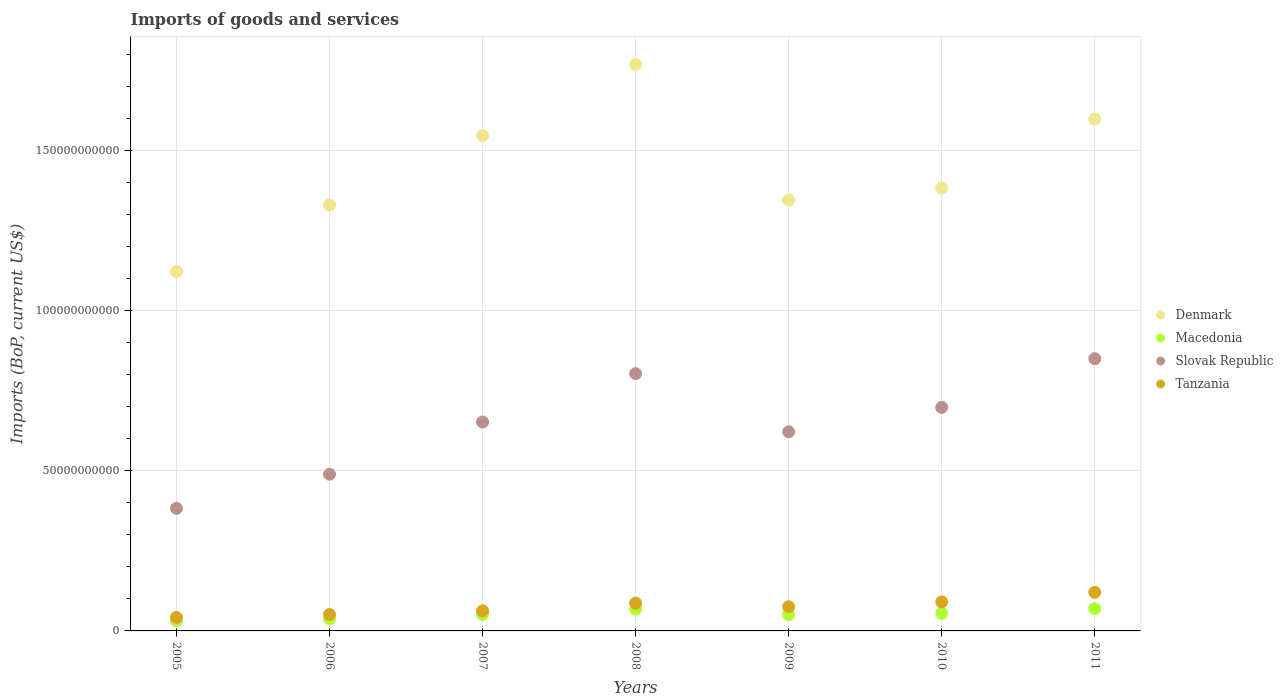How many different coloured dotlines are there?
Make the answer very short. 4. Is the number of dotlines equal to the number of legend labels?
Your response must be concise. Yes. What is the amount spent on imports in Slovak Republic in 2005?
Make the answer very short. 3.82e+1. Across all years, what is the maximum amount spent on imports in Denmark?
Make the answer very short. 1.77e+11. Across all years, what is the minimum amount spent on imports in Denmark?
Your answer should be very brief. 1.12e+11. In which year was the amount spent on imports in Denmark maximum?
Offer a very short reply. 2008. What is the total amount spent on imports in Macedonia in the graph?
Give a very brief answer. 3.65e+1. What is the difference between the amount spent on imports in Macedonia in 2005 and that in 2011?
Give a very brief answer. -3.75e+09. What is the difference between the amount spent on imports in Tanzania in 2011 and the amount spent on imports in Denmark in 2008?
Give a very brief answer. -1.65e+11. What is the average amount spent on imports in Macedonia per year?
Offer a terse response. 5.22e+09. In the year 2007, what is the difference between the amount spent on imports in Denmark and amount spent on imports in Tanzania?
Your answer should be compact. 1.48e+11. In how many years, is the amount spent on imports in Tanzania greater than 170000000000 US$?
Provide a short and direct response. 0. What is the ratio of the amount spent on imports in Slovak Republic in 2006 to that in 2011?
Provide a short and direct response. 0.58. Is the amount spent on imports in Denmark in 2007 less than that in 2009?
Make the answer very short. No. What is the difference between the highest and the second highest amount spent on imports in Tanzania?
Give a very brief answer. 2.98e+09. What is the difference between the highest and the lowest amount spent on imports in Macedonia?
Keep it short and to the point. 3.75e+09. Is the sum of the amount spent on imports in Tanzania in 2005 and 2011 greater than the maximum amount spent on imports in Denmark across all years?
Your answer should be very brief. No. Is it the case that in every year, the sum of the amount spent on imports in Slovak Republic and amount spent on imports in Tanzania  is greater than the amount spent on imports in Denmark?
Offer a very short reply. No. How many dotlines are there?
Your answer should be very brief. 4. How many years are there in the graph?
Make the answer very short. 7. How are the legend labels stacked?
Offer a very short reply. Vertical. What is the title of the graph?
Provide a short and direct response. Imports of goods and services. Does "Turkey" appear as one of the legend labels in the graph?
Offer a terse response. No. What is the label or title of the X-axis?
Your answer should be compact. Years. What is the label or title of the Y-axis?
Ensure brevity in your answer.  Imports (BoP, current US$). What is the Imports (BoP, current US$) of Denmark in 2005?
Make the answer very short. 1.12e+11. What is the Imports (BoP, current US$) in Macedonia in 2005?
Give a very brief answer. 3.19e+09. What is the Imports (BoP, current US$) of Slovak Republic in 2005?
Ensure brevity in your answer.  3.82e+1. What is the Imports (BoP, current US$) of Tanzania in 2005?
Ensure brevity in your answer.  4.20e+09. What is the Imports (BoP, current US$) of Denmark in 2006?
Provide a short and direct response. 1.33e+11. What is the Imports (BoP, current US$) of Macedonia in 2006?
Provide a short and direct response. 3.77e+09. What is the Imports (BoP, current US$) of Slovak Republic in 2006?
Your answer should be compact. 4.89e+1. What is the Imports (BoP, current US$) of Tanzania in 2006?
Your response must be concise. 5.11e+09. What is the Imports (BoP, current US$) of Denmark in 2007?
Your answer should be very brief. 1.55e+11. What is the Imports (BoP, current US$) of Macedonia in 2007?
Your answer should be very brief. 5.20e+09. What is the Imports (BoP, current US$) of Slovak Republic in 2007?
Keep it short and to the point. 6.52e+1. What is the Imports (BoP, current US$) in Tanzania in 2007?
Your answer should be very brief. 6.27e+09. What is the Imports (BoP, current US$) of Denmark in 2008?
Keep it short and to the point. 1.77e+11. What is the Imports (BoP, current US$) of Macedonia in 2008?
Offer a very short reply. 6.82e+09. What is the Imports (BoP, current US$) of Slovak Republic in 2008?
Your answer should be compact. 8.03e+1. What is the Imports (BoP, current US$) of Tanzania in 2008?
Your answer should be very brief. 8.67e+09. What is the Imports (BoP, current US$) in Denmark in 2009?
Make the answer very short. 1.34e+11. What is the Imports (BoP, current US$) in Macedonia in 2009?
Ensure brevity in your answer.  5.13e+09. What is the Imports (BoP, current US$) of Slovak Republic in 2009?
Your answer should be compact. 6.21e+1. What is the Imports (BoP, current US$) in Tanzania in 2009?
Ensure brevity in your answer.  7.56e+09. What is the Imports (BoP, current US$) of Denmark in 2010?
Provide a short and direct response. 1.38e+11. What is the Imports (BoP, current US$) of Macedonia in 2010?
Your answer should be very brief. 5.46e+09. What is the Imports (BoP, current US$) in Slovak Republic in 2010?
Your answer should be compact. 6.98e+1. What is the Imports (BoP, current US$) of Tanzania in 2010?
Ensure brevity in your answer.  9.05e+09. What is the Imports (BoP, current US$) of Denmark in 2011?
Keep it short and to the point. 1.60e+11. What is the Imports (BoP, current US$) in Macedonia in 2011?
Offer a very short reply. 6.93e+09. What is the Imports (BoP, current US$) in Slovak Republic in 2011?
Offer a very short reply. 8.50e+1. What is the Imports (BoP, current US$) in Tanzania in 2011?
Your answer should be very brief. 1.20e+1. Across all years, what is the maximum Imports (BoP, current US$) in Denmark?
Your answer should be very brief. 1.77e+11. Across all years, what is the maximum Imports (BoP, current US$) in Macedonia?
Make the answer very short. 6.93e+09. Across all years, what is the maximum Imports (BoP, current US$) of Slovak Republic?
Give a very brief answer. 8.50e+1. Across all years, what is the maximum Imports (BoP, current US$) in Tanzania?
Your answer should be very brief. 1.20e+1. Across all years, what is the minimum Imports (BoP, current US$) in Denmark?
Provide a succinct answer. 1.12e+11. Across all years, what is the minimum Imports (BoP, current US$) in Macedonia?
Your response must be concise. 3.19e+09. Across all years, what is the minimum Imports (BoP, current US$) of Slovak Republic?
Make the answer very short. 3.82e+1. Across all years, what is the minimum Imports (BoP, current US$) in Tanzania?
Give a very brief answer. 4.20e+09. What is the total Imports (BoP, current US$) of Denmark in the graph?
Provide a short and direct response. 1.01e+12. What is the total Imports (BoP, current US$) in Macedonia in the graph?
Your response must be concise. 3.65e+1. What is the total Imports (BoP, current US$) of Slovak Republic in the graph?
Ensure brevity in your answer.  4.50e+11. What is the total Imports (BoP, current US$) of Tanzania in the graph?
Make the answer very short. 5.29e+1. What is the difference between the Imports (BoP, current US$) in Denmark in 2005 and that in 2006?
Give a very brief answer. -2.08e+1. What is the difference between the Imports (BoP, current US$) in Macedonia in 2005 and that in 2006?
Your response must be concise. -5.85e+08. What is the difference between the Imports (BoP, current US$) in Slovak Republic in 2005 and that in 2006?
Make the answer very short. -1.07e+1. What is the difference between the Imports (BoP, current US$) in Tanzania in 2005 and that in 2006?
Your answer should be very brief. -9.09e+08. What is the difference between the Imports (BoP, current US$) in Denmark in 2005 and that in 2007?
Your answer should be very brief. -4.24e+1. What is the difference between the Imports (BoP, current US$) of Macedonia in 2005 and that in 2007?
Make the answer very short. -2.01e+09. What is the difference between the Imports (BoP, current US$) in Slovak Republic in 2005 and that in 2007?
Your answer should be very brief. -2.70e+1. What is the difference between the Imports (BoP, current US$) of Tanzania in 2005 and that in 2007?
Give a very brief answer. -2.07e+09. What is the difference between the Imports (BoP, current US$) in Denmark in 2005 and that in 2008?
Provide a short and direct response. -6.47e+1. What is the difference between the Imports (BoP, current US$) in Macedonia in 2005 and that in 2008?
Ensure brevity in your answer.  -3.63e+09. What is the difference between the Imports (BoP, current US$) of Slovak Republic in 2005 and that in 2008?
Provide a succinct answer. -4.20e+1. What is the difference between the Imports (BoP, current US$) of Tanzania in 2005 and that in 2008?
Provide a short and direct response. -4.47e+09. What is the difference between the Imports (BoP, current US$) of Denmark in 2005 and that in 2009?
Offer a terse response. -2.23e+1. What is the difference between the Imports (BoP, current US$) of Macedonia in 2005 and that in 2009?
Your answer should be compact. -1.94e+09. What is the difference between the Imports (BoP, current US$) of Slovak Republic in 2005 and that in 2009?
Ensure brevity in your answer.  -2.39e+1. What is the difference between the Imports (BoP, current US$) of Tanzania in 2005 and that in 2009?
Provide a short and direct response. -3.35e+09. What is the difference between the Imports (BoP, current US$) in Denmark in 2005 and that in 2010?
Provide a short and direct response. -2.61e+1. What is the difference between the Imports (BoP, current US$) of Macedonia in 2005 and that in 2010?
Give a very brief answer. -2.28e+09. What is the difference between the Imports (BoP, current US$) in Slovak Republic in 2005 and that in 2010?
Keep it short and to the point. -3.15e+1. What is the difference between the Imports (BoP, current US$) in Tanzania in 2005 and that in 2010?
Ensure brevity in your answer.  -4.85e+09. What is the difference between the Imports (BoP, current US$) in Denmark in 2005 and that in 2011?
Offer a very short reply. -4.76e+1. What is the difference between the Imports (BoP, current US$) of Macedonia in 2005 and that in 2011?
Your answer should be compact. -3.75e+09. What is the difference between the Imports (BoP, current US$) of Slovak Republic in 2005 and that in 2011?
Provide a succinct answer. -4.67e+1. What is the difference between the Imports (BoP, current US$) of Tanzania in 2005 and that in 2011?
Provide a succinct answer. -7.83e+09. What is the difference between the Imports (BoP, current US$) of Denmark in 2006 and that in 2007?
Give a very brief answer. -2.17e+1. What is the difference between the Imports (BoP, current US$) of Macedonia in 2006 and that in 2007?
Provide a short and direct response. -1.43e+09. What is the difference between the Imports (BoP, current US$) of Slovak Republic in 2006 and that in 2007?
Your answer should be very brief. -1.63e+1. What is the difference between the Imports (BoP, current US$) in Tanzania in 2006 and that in 2007?
Your response must be concise. -1.16e+09. What is the difference between the Imports (BoP, current US$) in Denmark in 2006 and that in 2008?
Offer a very short reply. -4.39e+1. What is the difference between the Imports (BoP, current US$) of Macedonia in 2006 and that in 2008?
Make the answer very short. -3.05e+09. What is the difference between the Imports (BoP, current US$) in Slovak Republic in 2006 and that in 2008?
Offer a terse response. -3.14e+1. What is the difference between the Imports (BoP, current US$) of Tanzania in 2006 and that in 2008?
Your response must be concise. -3.56e+09. What is the difference between the Imports (BoP, current US$) in Denmark in 2006 and that in 2009?
Ensure brevity in your answer.  -1.55e+09. What is the difference between the Imports (BoP, current US$) in Macedonia in 2006 and that in 2009?
Provide a succinct answer. -1.36e+09. What is the difference between the Imports (BoP, current US$) in Slovak Republic in 2006 and that in 2009?
Provide a succinct answer. -1.32e+1. What is the difference between the Imports (BoP, current US$) of Tanzania in 2006 and that in 2009?
Your answer should be very brief. -2.44e+09. What is the difference between the Imports (BoP, current US$) in Denmark in 2006 and that in 2010?
Give a very brief answer. -5.30e+09. What is the difference between the Imports (BoP, current US$) in Macedonia in 2006 and that in 2010?
Ensure brevity in your answer.  -1.69e+09. What is the difference between the Imports (BoP, current US$) of Slovak Republic in 2006 and that in 2010?
Provide a succinct answer. -2.09e+1. What is the difference between the Imports (BoP, current US$) of Tanzania in 2006 and that in 2010?
Ensure brevity in your answer.  -3.94e+09. What is the difference between the Imports (BoP, current US$) in Denmark in 2006 and that in 2011?
Your answer should be very brief. -2.68e+1. What is the difference between the Imports (BoP, current US$) in Macedonia in 2006 and that in 2011?
Offer a terse response. -3.16e+09. What is the difference between the Imports (BoP, current US$) in Slovak Republic in 2006 and that in 2011?
Provide a short and direct response. -3.61e+1. What is the difference between the Imports (BoP, current US$) in Tanzania in 2006 and that in 2011?
Offer a very short reply. -6.92e+09. What is the difference between the Imports (BoP, current US$) in Denmark in 2007 and that in 2008?
Provide a short and direct response. -2.22e+1. What is the difference between the Imports (BoP, current US$) in Macedonia in 2007 and that in 2008?
Provide a short and direct response. -1.62e+09. What is the difference between the Imports (BoP, current US$) in Slovak Republic in 2007 and that in 2008?
Give a very brief answer. -1.51e+1. What is the difference between the Imports (BoP, current US$) of Tanzania in 2007 and that in 2008?
Your response must be concise. -2.40e+09. What is the difference between the Imports (BoP, current US$) of Denmark in 2007 and that in 2009?
Make the answer very short. 2.01e+1. What is the difference between the Imports (BoP, current US$) in Macedonia in 2007 and that in 2009?
Keep it short and to the point. 6.79e+07. What is the difference between the Imports (BoP, current US$) of Slovak Republic in 2007 and that in 2009?
Your answer should be compact. 3.06e+09. What is the difference between the Imports (BoP, current US$) in Tanzania in 2007 and that in 2009?
Make the answer very short. -1.28e+09. What is the difference between the Imports (BoP, current US$) of Denmark in 2007 and that in 2010?
Provide a succinct answer. 1.64e+1. What is the difference between the Imports (BoP, current US$) in Macedonia in 2007 and that in 2010?
Provide a short and direct response. -2.63e+08. What is the difference between the Imports (BoP, current US$) in Slovak Republic in 2007 and that in 2010?
Offer a very short reply. -4.56e+09. What is the difference between the Imports (BoP, current US$) in Tanzania in 2007 and that in 2010?
Your answer should be compact. -2.78e+09. What is the difference between the Imports (BoP, current US$) in Denmark in 2007 and that in 2011?
Offer a very short reply. -5.16e+09. What is the difference between the Imports (BoP, current US$) in Macedonia in 2007 and that in 2011?
Keep it short and to the point. -1.73e+09. What is the difference between the Imports (BoP, current US$) in Slovak Republic in 2007 and that in 2011?
Your response must be concise. -1.98e+1. What is the difference between the Imports (BoP, current US$) of Tanzania in 2007 and that in 2011?
Keep it short and to the point. -5.76e+09. What is the difference between the Imports (BoP, current US$) in Denmark in 2008 and that in 2009?
Give a very brief answer. 4.23e+1. What is the difference between the Imports (BoP, current US$) in Macedonia in 2008 and that in 2009?
Offer a terse response. 1.69e+09. What is the difference between the Imports (BoP, current US$) of Slovak Republic in 2008 and that in 2009?
Keep it short and to the point. 1.81e+1. What is the difference between the Imports (BoP, current US$) in Tanzania in 2008 and that in 2009?
Your answer should be very brief. 1.12e+09. What is the difference between the Imports (BoP, current US$) of Denmark in 2008 and that in 2010?
Keep it short and to the point. 3.86e+1. What is the difference between the Imports (BoP, current US$) of Macedonia in 2008 and that in 2010?
Keep it short and to the point. 1.36e+09. What is the difference between the Imports (BoP, current US$) of Slovak Republic in 2008 and that in 2010?
Provide a short and direct response. 1.05e+1. What is the difference between the Imports (BoP, current US$) in Tanzania in 2008 and that in 2010?
Provide a short and direct response. -3.80e+08. What is the difference between the Imports (BoP, current US$) of Denmark in 2008 and that in 2011?
Keep it short and to the point. 1.71e+1. What is the difference between the Imports (BoP, current US$) in Macedonia in 2008 and that in 2011?
Your answer should be compact. -1.15e+08. What is the difference between the Imports (BoP, current US$) of Slovak Republic in 2008 and that in 2011?
Offer a very short reply. -4.66e+09. What is the difference between the Imports (BoP, current US$) of Tanzania in 2008 and that in 2011?
Your answer should be compact. -3.36e+09. What is the difference between the Imports (BoP, current US$) of Denmark in 2009 and that in 2010?
Make the answer very short. -3.75e+09. What is the difference between the Imports (BoP, current US$) of Macedonia in 2009 and that in 2010?
Provide a succinct answer. -3.31e+08. What is the difference between the Imports (BoP, current US$) in Slovak Republic in 2009 and that in 2010?
Make the answer very short. -7.61e+09. What is the difference between the Imports (BoP, current US$) of Tanzania in 2009 and that in 2010?
Your answer should be compact. -1.50e+09. What is the difference between the Imports (BoP, current US$) of Denmark in 2009 and that in 2011?
Offer a terse response. -2.53e+1. What is the difference between the Imports (BoP, current US$) in Macedonia in 2009 and that in 2011?
Provide a succinct answer. -1.80e+09. What is the difference between the Imports (BoP, current US$) in Slovak Republic in 2009 and that in 2011?
Your answer should be compact. -2.28e+1. What is the difference between the Imports (BoP, current US$) in Tanzania in 2009 and that in 2011?
Provide a short and direct response. -4.48e+09. What is the difference between the Imports (BoP, current US$) in Denmark in 2010 and that in 2011?
Keep it short and to the point. -2.15e+1. What is the difference between the Imports (BoP, current US$) in Macedonia in 2010 and that in 2011?
Your answer should be very brief. -1.47e+09. What is the difference between the Imports (BoP, current US$) in Slovak Republic in 2010 and that in 2011?
Provide a succinct answer. -1.52e+1. What is the difference between the Imports (BoP, current US$) in Tanzania in 2010 and that in 2011?
Your response must be concise. -2.98e+09. What is the difference between the Imports (BoP, current US$) of Denmark in 2005 and the Imports (BoP, current US$) of Macedonia in 2006?
Ensure brevity in your answer.  1.08e+11. What is the difference between the Imports (BoP, current US$) in Denmark in 2005 and the Imports (BoP, current US$) in Slovak Republic in 2006?
Give a very brief answer. 6.33e+1. What is the difference between the Imports (BoP, current US$) of Denmark in 2005 and the Imports (BoP, current US$) of Tanzania in 2006?
Offer a terse response. 1.07e+11. What is the difference between the Imports (BoP, current US$) in Macedonia in 2005 and the Imports (BoP, current US$) in Slovak Republic in 2006?
Your answer should be very brief. -4.57e+1. What is the difference between the Imports (BoP, current US$) in Macedonia in 2005 and the Imports (BoP, current US$) in Tanzania in 2006?
Give a very brief answer. -1.93e+09. What is the difference between the Imports (BoP, current US$) of Slovak Republic in 2005 and the Imports (BoP, current US$) of Tanzania in 2006?
Your answer should be very brief. 3.31e+1. What is the difference between the Imports (BoP, current US$) in Denmark in 2005 and the Imports (BoP, current US$) in Macedonia in 2007?
Keep it short and to the point. 1.07e+11. What is the difference between the Imports (BoP, current US$) of Denmark in 2005 and the Imports (BoP, current US$) of Slovak Republic in 2007?
Provide a short and direct response. 4.69e+1. What is the difference between the Imports (BoP, current US$) in Denmark in 2005 and the Imports (BoP, current US$) in Tanzania in 2007?
Your response must be concise. 1.06e+11. What is the difference between the Imports (BoP, current US$) in Macedonia in 2005 and the Imports (BoP, current US$) in Slovak Republic in 2007?
Your response must be concise. -6.20e+1. What is the difference between the Imports (BoP, current US$) of Macedonia in 2005 and the Imports (BoP, current US$) of Tanzania in 2007?
Give a very brief answer. -3.09e+09. What is the difference between the Imports (BoP, current US$) of Slovak Republic in 2005 and the Imports (BoP, current US$) of Tanzania in 2007?
Give a very brief answer. 3.20e+1. What is the difference between the Imports (BoP, current US$) in Denmark in 2005 and the Imports (BoP, current US$) in Macedonia in 2008?
Give a very brief answer. 1.05e+11. What is the difference between the Imports (BoP, current US$) in Denmark in 2005 and the Imports (BoP, current US$) in Slovak Republic in 2008?
Keep it short and to the point. 3.19e+1. What is the difference between the Imports (BoP, current US$) in Denmark in 2005 and the Imports (BoP, current US$) in Tanzania in 2008?
Give a very brief answer. 1.03e+11. What is the difference between the Imports (BoP, current US$) of Macedonia in 2005 and the Imports (BoP, current US$) of Slovak Republic in 2008?
Offer a terse response. -7.71e+1. What is the difference between the Imports (BoP, current US$) in Macedonia in 2005 and the Imports (BoP, current US$) in Tanzania in 2008?
Offer a very short reply. -5.49e+09. What is the difference between the Imports (BoP, current US$) of Slovak Republic in 2005 and the Imports (BoP, current US$) of Tanzania in 2008?
Give a very brief answer. 2.96e+1. What is the difference between the Imports (BoP, current US$) of Denmark in 2005 and the Imports (BoP, current US$) of Macedonia in 2009?
Your response must be concise. 1.07e+11. What is the difference between the Imports (BoP, current US$) in Denmark in 2005 and the Imports (BoP, current US$) in Slovak Republic in 2009?
Your answer should be very brief. 5.00e+1. What is the difference between the Imports (BoP, current US$) in Denmark in 2005 and the Imports (BoP, current US$) in Tanzania in 2009?
Keep it short and to the point. 1.05e+11. What is the difference between the Imports (BoP, current US$) of Macedonia in 2005 and the Imports (BoP, current US$) of Slovak Republic in 2009?
Your response must be concise. -5.90e+1. What is the difference between the Imports (BoP, current US$) of Macedonia in 2005 and the Imports (BoP, current US$) of Tanzania in 2009?
Your answer should be compact. -4.37e+09. What is the difference between the Imports (BoP, current US$) in Slovak Republic in 2005 and the Imports (BoP, current US$) in Tanzania in 2009?
Offer a terse response. 3.07e+1. What is the difference between the Imports (BoP, current US$) of Denmark in 2005 and the Imports (BoP, current US$) of Macedonia in 2010?
Your response must be concise. 1.07e+11. What is the difference between the Imports (BoP, current US$) of Denmark in 2005 and the Imports (BoP, current US$) of Slovak Republic in 2010?
Provide a short and direct response. 4.24e+1. What is the difference between the Imports (BoP, current US$) of Denmark in 2005 and the Imports (BoP, current US$) of Tanzania in 2010?
Keep it short and to the point. 1.03e+11. What is the difference between the Imports (BoP, current US$) of Macedonia in 2005 and the Imports (BoP, current US$) of Slovak Republic in 2010?
Your answer should be very brief. -6.66e+1. What is the difference between the Imports (BoP, current US$) in Macedonia in 2005 and the Imports (BoP, current US$) in Tanzania in 2010?
Provide a short and direct response. -5.87e+09. What is the difference between the Imports (BoP, current US$) of Slovak Republic in 2005 and the Imports (BoP, current US$) of Tanzania in 2010?
Ensure brevity in your answer.  2.92e+1. What is the difference between the Imports (BoP, current US$) of Denmark in 2005 and the Imports (BoP, current US$) of Macedonia in 2011?
Offer a very short reply. 1.05e+11. What is the difference between the Imports (BoP, current US$) in Denmark in 2005 and the Imports (BoP, current US$) in Slovak Republic in 2011?
Keep it short and to the point. 2.72e+1. What is the difference between the Imports (BoP, current US$) of Denmark in 2005 and the Imports (BoP, current US$) of Tanzania in 2011?
Keep it short and to the point. 1.00e+11. What is the difference between the Imports (BoP, current US$) of Macedonia in 2005 and the Imports (BoP, current US$) of Slovak Republic in 2011?
Make the answer very short. -8.18e+1. What is the difference between the Imports (BoP, current US$) of Macedonia in 2005 and the Imports (BoP, current US$) of Tanzania in 2011?
Your answer should be very brief. -8.85e+09. What is the difference between the Imports (BoP, current US$) in Slovak Republic in 2005 and the Imports (BoP, current US$) in Tanzania in 2011?
Your answer should be compact. 2.62e+1. What is the difference between the Imports (BoP, current US$) of Denmark in 2006 and the Imports (BoP, current US$) of Macedonia in 2007?
Give a very brief answer. 1.28e+11. What is the difference between the Imports (BoP, current US$) of Denmark in 2006 and the Imports (BoP, current US$) of Slovak Republic in 2007?
Your response must be concise. 6.77e+1. What is the difference between the Imports (BoP, current US$) in Denmark in 2006 and the Imports (BoP, current US$) in Tanzania in 2007?
Give a very brief answer. 1.27e+11. What is the difference between the Imports (BoP, current US$) of Macedonia in 2006 and the Imports (BoP, current US$) of Slovak Republic in 2007?
Offer a very short reply. -6.14e+1. What is the difference between the Imports (BoP, current US$) in Macedonia in 2006 and the Imports (BoP, current US$) in Tanzania in 2007?
Provide a short and direct response. -2.50e+09. What is the difference between the Imports (BoP, current US$) of Slovak Republic in 2006 and the Imports (BoP, current US$) of Tanzania in 2007?
Keep it short and to the point. 4.26e+1. What is the difference between the Imports (BoP, current US$) in Denmark in 2006 and the Imports (BoP, current US$) in Macedonia in 2008?
Provide a succinct answer. 1.26e+11. What is the difference between the Imports (BoP, current US$) of Denmark in 2006 and the Imports (BoP, current US$) of Slovak Republic in 2008?
Make the answer very short. 5.26e+1. What is the difference between the Imports (BoP, current US$) in Denmark in 2006 and the Imports (BoP, current US$) in Tanzania in 2008?
Provide a short and direct response. 1.24e+11. What is the difference between the Imports (BoP, current US$) of Macedonia in 2006 and the Imports (BoP, current US$) of Slovak Republic in 2008?
Offer a very short reply. -7.65e+1. What is the difference between the Imports (BoP, current US$) of Macedonia in 2006 and the Imports (BoP, current US$) of Tanzania in 2008?
Make the answer very short. -4.90e+09. What is the difference between the Imports (BoP, current US$) in Slovak Republic in 2006 and the Imports (BoP, current US$) in Tanzania in 2008?
Your answer should be compact. 4.02e+1. What is the difference between the Imports (BoP, current US$) of Denmark in 2006 and the Imports (BoP, current US$) of Macedonia in 2009?
Your answer should be very brief. 1.28e+11. What is the difference between the Imports (BoP, current US$) in Denmark in 2006 and the Imports (BoP, current US$) in Slovak Republic in 2009?
Offer a terse response. 7.08e+1. What is the difference between the Imports (BoP, current US$) in Denmark in 2006 and the Imports (BoP, current US$) in Tanzania in 2009?
Your answer should be compact. 1.25e+11. What is the difference between the Imports (BoP, current US$) in Macedonia in 2006 and the Imports (BoP, current US$) in Slovak Republic in 2009?
Keep it short and to the point. -5.84e+1. What is the difference between the Imports (BoP, current US$) of Macedonia in 2006 and the Imports (BoP, current US$) of Tanzania in 2009?
Provide a short and direct response. -3.78e+09. What is the difference between the Imports (BoP, current US$) of Slovak Republic in 2006 and the Imports (BoP, current US$) of Tanzania in 2009?
Offer a terse response. 4.13e+1. What is the difference between the Imports (BoP, current US$) in Denmark in 2006 and the Imports (BoP, current US$) in Macedonia in 2010?
Offer a terse response. 1.27e+11. What is the difference between the Imports (BoP, current US$) in Denmark in 2006 and the Imports (BoP, current US$) in Slovak Republic in 2010?
Provide a succinct answer. 6.32e+1. What is the difference between the Imports (BoP, current US$) in Denmark in 2006 and the Imports (BoP, current US$) in Tanzania in 2010?
Keep it short and to the point. 1.24e+11. What is the difference between the Imports (BoP, current US$) in Macedonia in 2006 and the Imports (BoP, current US$) in Slovak Republic in 2010?
Make the answer very short. -6.60e+1. What is the difference between the Imports (BoP, current US$) in Macedonia in 2006 and the Imports (BoP, current US$) in Tanzania in 2010?
Ensure brevity in your answer.  -5.28e+09. What is the difference between the Imports (BoP, current US$) in Slovak Republic in 2006 and the Imports (BoP, current US$) in Tanzania in 2010?
Your answer should be very brief. 3.98e+1. What is the difference between the Imports (BoP, current US$) in Denmark in 2006 and the Imports (BoP, current US$) in Macedonia in 2011?
Keep it short and to the point. 1.26e+11. What is the difference between the Imports (BoP, current US$) of Denmark in 2006 and the Imports (BoP, current US$) of Slovak Republic in 2011?
Ensure brevity in your answer.  4.80e+1. What is the difference between the Imports (BoP, current US$) in Denmark in 2006 and the Imports (BoP, current US$) in Tanzania in 2011?
Your answer should be very brief. 1.21e+11. What is the difference between the Imports (BoP, current US$) of Macedonia in 2006 and the Imports (BoP, current US$) of Slovak Republic in 2011?
Your response must be concise. -8.12e+1. What is the difference between the Imports (BoP, current US$) of Macedonia in 2006 and the Imports (BoP, current US$) of Tanzania in 2011?
Your response must be concise. -8.26e+09. What is the difference between the Imports (BoP, current US$) in Slovak Republic in 2006 and the Imports (BoP, current US$) in Tanzania in 2011?
Give a very brief answer. 3.69e+1. What is the difference between the Imports (BoP, current US$) in Denmark in 2007 and the Imports (BoP, current US$) in Macedonia in 2008?
Make the answer very short. 1.48e+11. What is the difference between the Imports (BoP, current US$) in Denmark in 2007 and the Imports (BoP, current US$) in Slovak Republic in 2008?
Your answer should be compact. 7.43e+1. What is the difference between the Imports (BoP, current US$) in Denmark in 2007 and the Imports (BoP, current US$) in Tanzania in 2008?
Your answer should be very brief. 1.46e+11. What is the difference between the Imports (BoP, current US$) of Macedonia in 2007 and the Imports (BoP, current US$) of Slovak Republic in 2008?
Make the answer very short. -7.51e+1. What is the difference between the Imports (BoP, current US$) in Macedonia in 2007 and the Imports (BoP, current US$) in Tanzania in 2008?
Offer a terse response. -3.47e+09. What is the difference between the Imports (BoP, current US$) in Slovak Republic in 2007 and the Imports (BoP, current US$) in Tanzania in 2008?
Offer a very short reply. 5.65e+1. What is the difference between the Imports (BoP, current US$) in Denmark in 2007 and the Imports (BoP, current US$) in Macedonia in 2009?
Keep it short and to the point. 1.49e+11. What is the difference between the Imports (BoP, current US$) in Denmark in 2007 and the Imports (BoP, current US$) in Slovak Republic in 2009?
Your response must be concise. 9.24e+1. What is the difference between the Imports (BoP, current US$) in Denmark in 2007 and the Imports (BoP, current US$) in Tanzania in 2009?
Keep it short and to the point. 1.47e+11. What is the difference between the Imports (BoP, current US$) of Macedonia in 2007 and the Imports (BoP, current US$) of Slovak Republic in 2009?
Your answer should be very brief. -5.69e+1. What is the difference between the Imports (BoP, current US$) in Macedonia in 2007 and the Imports (BoP, current US$) in Tanzania in 2009?
Offer a terse response. -2.36e+09. What is the difference between the Imports (BoP, current US$) in Slovak Republic in 2007 and the Imports (BoP, current US$) in Tanzania in 2009?
Your answer should be very brief. 5.77e+1. What is the difference between the Imports (BoP, current US$) of Denmark in 2007 and the Imports (BoP, current US$) of Macedonia in 2010?
Provide a succinct answer. 1.49e+11. What is the difference between the Imports (BoP, current US$) in Denmark in 2007 and the Imports (BoP, current US$) in Slovak Republic in 2010?
Give a very brief answer. 8.48e+1. What is the difference between the Imports (BoP, current US$) in Denmark in 2007 and the Imports (BoP, current US$) in Tanzania in 2010?
Your response must be concise. 1.46e+11. What is the difference between the Imports (BoP, current US$) of Macedonia in 2007 and the Imports (BoP, current US$) of Slovak Republic in 2010?
Offer a very short reply. -6.46e+1. What is the difference between the Imports (BoP, current US$) of Macedonia in 2007 and the Imports (BoP, current US$) of Tanzania in 2010?
Your response must be concise. -3.85e+09. What is the difference between the Imports (BoP, current US$) in Slovak Republic in 2007 and the Imports (BoP, current US$) in Tanzania in 2010?
Your answer should be very brief. 5.62e+1. What is the difference between the Imports (BoP, current US$) of Denmark in 2007 and the Imports (BoP, current US$) of Macedonia in 2011?
Keep it short and to the point. 1.48e+11. What is the difference between the Imports (BoP, current US$) of Denmark in 2007 and the Imports (BoP, current US$) of Slovak Republic in 2011?
Provide a short and direct response. 6.96e+1. What is the difference between the Imports (BoP, current US$) in Denmark in 2007 and the Imports (BoP, current US$) in Tanzania in 2011?
Keep it short and to the point. 1.43e+11. What is the difference between the Imports (BoP, current US$) of Macedonia in 2007 and the Imports (BoP, current US$) of Slovak Republic in 2011?
Provide a short and direct response. -7.98e+1. What is the difference between the Imports (BoP, current US$) in Macedonia in 2007 and the Imports (BoP, current US$) in Tanzania in 2011?
Make the answer very short. -6.84e+09. What is the difference between the Imports (BoP, current US$) of Slovak Republic in 2007 and the Imports (BoP, current US$) of Tanzania in 2011?
Give a very brief answer. 5.32e+1. What is the difference between the Imports (BoP, current US$) in Denmark in 2008 and the Imports (BoP, current US$) in Macedonia in 2009?
Provide a short and direct response. 1.72e+11. What is the difference between the Imports (BoP, current US$) of Denmark in 2008 and the Imports (BoP, current US$) of Slovak Republic in 2009?
Provide a succinct answer. 1.15e+11. What is the difference between the Imports (BoP, current US$) of Denmark in 2008 and the Imports (BoP, current US$) of Tanzania in 2009?
Your answer should be compact. 1.69e+11. What is the difference between the Imports (BoP, current US$) of Macedonia in 2008 and the Imports (BoP, current US$) of Slovak Republic in 2009?
Make the answer very short. -5.53e+1. What is the difference between the Imports (BoP, current US$) in Macedonia in 2008 and the Imports (BoP, current US$) in Tanzania in 2009?
Provide a short and direct response. -7.37e+08. What is the difference between the Imports (BoP, current US$) of Slovak Republic in 2008 and the Imports (BoP, current US$) of Tanzania in 2009?
Ensure brevity in your answer.  7.27e+1. What is the difference between the Imports (BoP, current US$) of Denmark in 2008 and the Imports (BoP, current US$) of Macedonia in 2010?
Keep it short and to the point. 1.71e+11. What is the difference between the Imports (BoP, current US$) of Denmark in 2008 and the Imports (BoP, current US$) of Slovak Republic in 2010?
Ensure brevity in your answer.  1.07e+11. What is the difference between the Imports (BoP, current US$) of Denmark in 2008 and the Imports (BoP, current US$) of Tanzania in 2010?
Your answer should be very brief. 1.68e+11. What is the difference between the Imports (BoP, current US$) in Macedonia in 2008 and the Imports (BoP, current US$) in Slovak Republic in 2010?
Your response must be concise. -6.29e+1. What is the difference between the Imports (BoP, current US$) of Macedonia in 2008 and the Imports (BoP, current US$) of Tanzania in 2010?
Provide a short and direct response. -2.23e+09. What is the difference between the Imports (BoP, current US$) of Slovak Republic in 2008 and the Imports (BoP, current US$) of Tanzania in 2010?
Offer a very short reply. 7.12e+1. What is the difference between the Imports (BoP, current US$) of Denmark in 2008 and the Imports (BoP, current US$) of Macedonia in 2011?
Provide a short and direct response. 1.70e+11. What is the difference between the Imports (BoP, current US$) in Denmark in 2008 and the Imports (BoP, current US$) in Slovak Republic in 2011?
Offer a terse response. 9.19e+1. What is the difference between the Imports (BoP, current US$) of Denmark in 2008 and the Imports (BoP, current US$) of Tanzania in 2011?
Make the answer very short. 1.65e+11. What is the difference between the Imports (BoP, current US$) of Macedonia in 2008 and the Imports (BoP, current US$) of Slovak Republic in 2011?
Your answer should be compact. -7.81e+1. What is the difference between the Imports (BoP, current US$) of Macedonia in 2008 and the Imports (BoP, current US$) of Tanzania in 2011?
Provide a succinct answer. -5.22e+09. What is the difference between the Imports (BoP, current US$) in Slovak Republic in 2008 and the Imports (BoP, current US$) in Tanzania in 2011?
Offer a very short reply. 6.83e+1. What is the difference between the Imports (BoP, current US$) of Denmark in 2009 and the Imports (BoP, current US$) of Macedonia in 2010?
Make the answer very short. 1.29e+11. What is the difference between the Imports (BoP, current US$) of Denmark in 2009 and the Imports (BoP, current US$) of Slovak Republic in 2010?
Make the answer very short. 6.47e+1. What is the difference between the Imports (BoP, current US$) of Denmark in 2009 and the Imports (BoP, current US$) of Tanzania in 2010?
Your answer should be very brief. 1.25e+11. What is the difference between the Imports (BoP, current US$) of Macedonia in 2009 and the Imports (BoP, current US$) of Slovak Republic in 2010?
Provide a short and direct response. -6.46e+1. What is the difference between the Imports (BoP, current US$) in Macedonia in 2009 and the Imports (BoP, current US$) in Tanzania in 2010?
Make the answer very short. -3.92e+09. What is the difference between the Imports (BoP, current US$) in Slovak Republic in 2009 and the Imports (BoP, current US$) in Tanzania in 2010?
Your response must be concise. 5.31e+1. What is the difference between the Imports (BoP, current US$) in Denmark in 2009 and the Imports (BoP, current US$) in Macedonia in 2011?
Make the answer very short. 1.28e+11. What is the difference between the Imports (BoP, current US$) in Denmark in 2009 and the Imports (BoP, current US$) in Slovak Republic in 2011?
Your answer should be very brief. 4.95e+1. What is the difference between the Imports (BoP, current US$) of Denmark in 2009 and the Imports (BoP, current US$) of Tanzania in 2011?
Offer a very short reply. 1.22e+11. What is the difference between the Imports (BoP, current US$) in Macedonia in 2009 and the Imports (BoP, current US$) in Slovak Republic in 2011?
Offer a terse response. -7.98e+1. What is the difference between the Imports (BoP, current US$) of Macedonia in 2009 and the Imports (BoP, current US$) of Tanzania in 2011?
Your answer should be compact. -6.90e+09. What is the difference between the Imports (BoP, current US$) in Slovak Republic in 2009 and the Imports (BoP, current US$) in Tanzania in 2011?
Offer a very short reply. 5.01e+1. What is the difference between the Imports (BoP, current US$) in Denmark in 2010 and the Imports (BoP, current US$) in Macedonia in 2011?
Offer a very short reply. 1.31e+11. What is the difference between the Imports (BoP, current US$) in Denmark in 2010 and the Imports (BoP, current US$) in Slovak Republic in 2011?
Offer a very short reply. 5.33e+1. What is the difference between the Imports (BoP, current US$) of Denmark in 2010 and the Imports (BoP, current US$) of Tanzania in 2011?
Ensure brevity in your answer.  1.26e+11. What is the difference between the Imports (BoP, current US$) of Macedonia in 2010 and the Imports (BoP, current US$) of Slovak Republic in 2011?
Ensure brevity in your answer.  -7.95e+1. What is the difference between the Imports (BoP, current US$) of Macedonia in 2010 and the Imports (BoP, current US$) of Tanzania in 2011?
Your response must be concise. -6.57e+09. What is the difference between the Imports (BoP, current US$) in Slovak Republic in 2010 and the Imports (BoP, current US$) in Tanzania in 2011?
Your answer should be very brief. 5.77e+1. What is the average Imports (BoP, current US$) in Denmark per year?
Your response must be concise. 1.44e+11. What is the average Imports (BoP, current US$) of Macedonia per year?
Your response must be concise. 5.22e+09. What is the average Imports (BoP, current US$) of Slovak Republic per year?
Your answer should be very brief. 6.42e+1. What is the average Imports (BoP, current US$) in Tanzania per year?
Your answer should be compact. 7.56e+09. In the year 2005, what is the difference between the Imports (BoP, current US$) in Denmark and Imports (BoP, current US$) in Macedonia?
Provide a short and direct response. 1.09e+11. In the year 2005, what is the difference between the Imports (BoP, current US$) of Denmark and Imports (BoP, current US$) of Slovak Republic?
Offer a very short reply. 7.39e+1. In the year 2005, what is the difference between the Imports (BoP, current US$) in Denmark and Imports (BoP, current US$) in Tanzania?
Keep it short and to the point. 1.08e+11. In the year 2005, what is the difference between the Imports (BoP, current US$) in Macedonia and Imports (BoP, current US$) in Slovak Republic?
Your answer should be very brief. -3.51e+1. In the year 2005, what is the difference between the Imports (BoP, current US$) in Macedonia and Imports (BoP, current US$) in Tanzania?
Provide a succinct answer. -1.02e+09. In the year 2005, what is the difference between the Imports (BoP, current US$) in Slovak Republic and Imports (BoP, current US$) in Tanzania?
Provide a succinct answer. 3.40e+1. In the year 2006, what is the difference between the Imports (BoP, current US$) in Denmark and Imports (BoP, current US$) in Macedonia?
Give a very brief answer. 1.29e+11. In the year 2006, what is the difference between the Imports (BoP, current US$) of Denmark and Imports (BoP, current US$) of Slovak Republic?
Make the answer very short. 8.40e+1. In the year 2006, what is the difference between the Imports (BoP, current US$) of Denmark and Imports (BoP, current US$) of Tanzania?
Your answer should be very brief. 1.28e+11. In the year 2006, what is the difference between the Imports (BoP, current US$) in Macedonia and Imports (BoP, current US$) in Slovak Republic?
Offer a very short reply. -4.51e+1. In the year 2006, what is the difference between the Imports (BoP, current US$) of Macedonia and Imports (BoP, current US$) of Tanzania?
Your answer should be very brief. -1.34e+09. In the year 2006, what is the difference between the Imports (BoP, current US$) in Slovak Republic and Imports (BoP, current US$) in Tanzania?
Give a very brief answer. 4.38e+1. In the year 2007, what is the difference between the Imports (BoP, current US$) of Denmark and Imports (BoP, current US$) of Macedonia?
Ensure brevity in your answer.  1.49e+11. In the year 2007, what is the difference between the Imports (BoP, current US$) in Denmark and Imports (BoP, current US$) in Slovak Republic?
Ensure brevity in your answer.  8.94e+1. In the year 2007, what is the difference between the Imports (BoP, current US$) of Denmark and Imports (BoP, current US$) of Tanzania?
Offer a terse response. 1.48e+11. In the year 2007, what is the difference between the Imports (BoP, current US$) of Macedonia and Imports (BoP, current US$) of Slovak Republic?
Provide a short and direct response. -6.00e+1. In the year 2007, what is the difference between the Imports (BoP, current US$) of Macedonia and Imports (BoP, current US$) of Tanzania?
Provide a short and direct response. -1.07e+09. In the year 2007, what is the difference between the Imports (BoP, current US$) in Slovak Republic and Imports (BoP, current US$) in Tanzania?
Offer a very short reply. 5.89e+1. In the year 2008, what is the difference between the Imports (BoP, current US$) in Denmark and Imports (BoP, current US$) in Macedonia?
Your answer should be compact. 1.70e+11. In the year 2008, what is the difference between the Imports (BoP, current US$) in Denmark and Imports (BoP, current US$) in Slovak Republic?
Your answer should be compact. 9.65e+1. In the year 2008, what is the difference between the Imports (BoP, current US$) in Denmark and Imports (BoP, current US$) in Tanzania?
Your answer should be compact. 1.68e+11. In the year 2008, what is the difference between the Imports (BoP, current US$) in Macedonia and Imports (BoP, current US$) in Slovak Republic?
Give a very brief answer. -7.35e+1. In the year 2008, what is the difference between the Imports (BoP, current US$) in Macedonia and Imports (BoP, current US$) in Tanzania?
Provide a short and direct response. -1.85e+09. In the year 2008, what is the difference between the Imports (BoP, current US$) of Slovak Republic and Imports (BoP, current US$) of Tanzania?
Give a very brief answer. 7.16e+1. In the year 2009, what is the difference between the Imports (BoP, current US$) in Denmark and Imports (BoP, current US$) in Macedonia?
Offer a very short reply. 1.29e+11. In the year 2009, what is the difference between the Imports (BoP, current US$) of Denmark and Imports (BoP, current US$) of Slovak Republic?
Keep it short and to the point. 7.23e+1. In the year 2009, what is the difference between the Imports (BoP, current US$) of Denmark and Imports (BoP, current US$) of Tanzania?
Provide a succinct answer. 1.27e+11. In the year 2009, what is the difference between the Imports (BoP, current US$) in Macedonia and Imports (BoP, current US$) in Slovak Republic?
Your answer should be compact. -5.70e+1. In the year 2009, what is the difference between the Imports (BoP, current US$) in Macedonia and Imports (BoP, current US$) in Tanzania?
Keep it short and to the point. -2.42e+09. In the year 2009, what is the difference between the Imports (BoP, current US$) in Slovak Republic and Imports (BoP, current US$) in Tanzania?
Offer a terse response. 5.46e+1. In the year 2010, what is the difference between the Imports (BoP, current US$) of Denmark and Imports (BoP, current US$) of Macedonia?
Offer a terse response. 1.33e+11. In the year 2010, what is the difference between the Imports (BoP, current US$) in Denmark and Imports (BoP, current US$) in Slovak Republic?
Provide a short and direct response. 6.85e+1. In the year 2010, what is the difference between the Imports (BoP, current US$) of Denmark and Imports (BoP, current US$) of Tanzania?
Your answer should be very brief. 1.29e+11. In the year 2010, what is the difference between the Imports (BoP, current US$) in Macedonia and Imports (BoP, current US$) in Slovak Republic?
Give a very brief answer. -6.43e+1. In the year 2010, what is the difference between the Imports (BoP, current US$) in Macedonia and Imports (BoP, current US$) in Tanzania?
Make the answer very short. -3.59e+09. In the year 2010, what is the difference between the Imports (BoP, current US$) in Slovak Republic and Imports (BoP, current US$) in Tanzania?
Ensure brevity in your answer.  6.07e+1. In the year 2011, what is the difference between the Imports (BoP, current US$) in Denmark and Imports (BoP, current US$) in Macedonia?
Provide a short and direct response. 1.53e+11. In the year 2011, what is the difference between the Imports (BoP, current US$) of Denmark and Imports (BoP, current US$) of Slovak Republic?
Offer a very short reply. 7.48e+1. In the year 2011, what is the difference between the Imports (BoP, current US$) in Denmark and Imports (BoP, current US$) in Tanzania?
Your answer should be compact. 1.48e+11. In the year 2011, what is the difference between the Imports (BoP, current US$) of Macedonia and Imports (BoP, current US$) of Slovak Republic?
Your answer should be compact. -7.80e+1. In the year 2011, what is the difference between the Imports (BoP, current US$) in Macedonia and Imports (BoP, current US$) in Tanzania?
Your answer should be compact. -5.10e+09. In the year 2011, what is the difference between the Imports (BoP, current US$) of Slovak Republic and Imports (BoP, current US$) of Tanzania?
Ensure brevity in your answer.  7.29e+1. What is the ratio of the Imports (BoP, current US$) in Denmark in 2005 to that in 2006?
Ensure brevity in your answer.  0.84. What is the ratio of the Imports (BoP, current US$) in Macedonia in 2005 to that in 2006?
Provide a short and direct response. 0.84. What is the ratio of the Imports (BoP, current US$) in Slovak Republic in 2005 to that in 2006?
Give a very brief answer. 0.78. What is the ratio of the Imports (BoP, current US$) in Tanzania in 2005 to that in 2006?
Provide a succinct answer. 0.82. What is the ratio of the Imports (BoP, current US$) of Denmark in 2005 to that in 2007?
Your answer should be very brief. 0.73. What is the ratio of the Imports (BoP, current US$) in Macedonia in 2005 to that in 2007?
Keep it short and to the point. 0.61. What is the ratio of the Imports (BoP, current US$) of Slovak Republic in 2005 to that in 2007?
Your response must be concise. 0.59. What is the ratio of the Imports (BoP, current US$) in Tanzania in 2005 to that in 2007?
Your response must be concise. 0.67. What is the ratio of the Imports (BoP, current US$) of Denmark in 2005 to that in 2008?
Your response must be concise. 0.63. What is the ratio of the Imports (BoP, current US$) of Macedonia in 2005 to that in 2008?
Provide a succinct answer. 0.47. What is the ratio of the Imports (BoP, current US$) of Slovak Republic in 2005 to that in 2008?
Keep it short and to the point. 0.48. What is the ratio of the Imports (BoP, current US$) in Tanzania in 2005 to that in 2008?
Your answer should be compact. 0.48. What is the ratio of the Imports (BoP, current US$) in Denmark in 2005 to that in 2009?
Your answer should be compact. 0.83. What is the ratio of the Imports (BoP, current US$) in Macedonia in 2005 to that in 2009?
Give a very brief answer. 0.62. What is the ratio of the Imports (BoP, current US$) of Slovak Republic in 2005 to that in 2009?
Offer a terse response. 0.62. What is the ratio of the Imports (BoP, current US$) of Tanzania in 2005 to that in 2009?
Your answer should be very brief. 0.56. What is the ratio of the Imports (BoP, current US$) in Denmark in 2005 to that in 2010?
Make the answer very short. 0.81. What is the ratio of the Imports (BoP, current US$) in Macedonia in 2005 to that in 2010?
Provide a short and direct response. 0.58. What is the ratio of the Imports (BoP, current US$) of Slovak Republic in 2005 to that in 2010?
Your answer should be very brief. 0.55. What is the ratio of the Imports (BoP, current US$) of Tanzania in 2005 to that in 2010?
Your response must be concise. 0.46. What is the ratio of the Imports (BoP, current US$) in Denmark in 2005 to that in 2011?
Your answer should be very brief. 0.7. What is the ratio of the Imports (BoP, current US$) in Macedonia in 2005 to that in 2011?
Offer a very short reply. 0.46. What is the ratio of the Imports (BoP, current US$) in Slovak Republic in 2005 to that in 2011?
Your response must be concise. 0.45. What is the ratio of the Imports (BoP, current US$) in Tanzania in 2005 to that in 2011?
Your answer should be compact. 0.35. What is the ratio of the Imports (BoP, current US$) of Denmark in 2006 to that in 2007?
Offer a very short reply. 0.86. What is the ratio of the Imports (BoP, current US$) in Macedonia in 2006 to that in 2007?
Offer a terse response. 0.73. What is the ratio of the Imports (BoP, current US$) in Tanzania in 2006 to that in 2007?
Keep it short and to the point. 0.81. What is the ratio of the Imports (BoP, current US$) of Denmark in 2006 to that in 2008?
Provide a short and direct response. 0.75. What is the ratio of the Imports (BoP, current US$) in Macedonia in 2006 to that in 2008?
Offer a very short reply. 0.55. What is the ratio of the Imports (BoP, current US$) in Slovak Republic in 2006 to that in 2008?
Your answer should be compact. 0.61. What is the ratio of the Imports (BoP, current US$) of Tanzania in 2006 to that in 2008?
Ensure brevity in your answer.  0.59. What is the ratio of the Imports (BoP, current US$) of Denmark in 2006 to that in 2009?
Make the answer very short. 0.99. What is the ratio of the Imports (BoP, current US$) of Macedonia in 2006 to that in 2009?
Make the answer very short. 0.73. What is the ratio of the Imports (BoP, current US$) in Slovak Republic in 2006 to that in 2009?
Provide a short and direct response. 0.79. What is the ratio of the Imports (BoP, current US$) of Tanzania in 2006 to that in 2009?
Give a very brief answer. 0.68. What is the ratio of the Imports (BoP, current US$) in Denmark in 2006 to that in 2010?
Your answer should be compact. 0.96. What is the ratio of the Imports (BoP, current US$) of Macedonia in 2006 to that in 2010?
Ensure brevity in your answer.  0.69. What is the ratio of the Imports (BoP, current US$) in Slovak Republic in 2006 to that in 2010?
Make the answer very short. 0.7. What is the ratio of the Imports (BoP, current US$) of Tanzania in 2006 to that in 2010?
Your answer should be compact. 0.56. What is the ratio of the Imports (BoP, current US$) of Denmark in 2006 to that in 2011?
Give a very brief answer. 0.83. What is the ratio of the Imports (BoP, current US$) of Macedonia in 2006 to that in 2011?
Provide a succinct answer. 0.54. What is the ratio of the Imports (BoP, current US$) of Slovak Republic in 2006 to that in 2011?
Provide a succinct answer. 0.58. What is the ratio of the Imports (BoP, current US$) of Tanzania in 2006 to that in 2011?
Your response must be concise. 0.42. What is the ratio of the Imports (BoP, current US$) of Denmark in 2007 to that in 2008?
Offer a very short reply. 0.87. What is the ratio of the Imports (BoP, current US$) in Macedonia in 2007 to that in 2008?
Offer a very short reply. 0.76. What is the ratio of the Imports (BoP, current US$) in Slovak Republic in 2007 to that in 2008?
Offer a very short reply. 0.81. What is the ratio of the Imports (BoP, current US$) of Tanzania in 2007 to that in 2008?
Your answer should be compact. 0.72. What is the ratio of the Imports (BoP, current US$) of Denmark in 2007 to that in 2009?
Give a very brief answer. 1.15. What is the ratio of the Imports (BoP, current US$) in Macedonia in 2007 to that in 2009?
Your response must be concise. 1.01. What is the ratio of the Imports (BoP, current US$) in Slovak Republic in 2007 to that in 2009?
Ensure brevity in your answer.  1.05. What is the ratio of the Imports (BoP, current US$) of Tanzania in 2007 to that in 2009?
Provide a succinct answer. 0.83. What is the ratio of the Imports (BoP, current US$) of Denmark in 2007 to that in 2010?
Offer a very short reply. 1.12. What is the ratio of the Imports (BoP, current US$) of Macedonia in 2007 to that in 2010?
Your response must be concise. 0.95. What is the ratio of the Imports (BoP, current US$) of Slovak Republic in 2007 to that in 2010?
Ensure brevity in your answer.  0.93. What is the ratio of the Imports (BoP, current US$) in Tanzania in 2007 to that in 2010?
Make the answer very short. 0.69. What is the ratio of the Imports (BoP, current US$) of Denmark in 2007 to that in 2011?
Provide a short and direct response. 0.97. What is the ratio of the Imports (BoP, current US$) of Macedonia in 2007 to that in 2011?
Give a very brief answer. 0.75. What is the ratio of the Imports (BoP, current US$) of Slovak Republic in 2007 to that in 2011?
Your answer should be very brief. 0.77. What is the ratio of the Imports (BoP, current US$) of Tanzania in 2007 to that in 2011?
Provide a succinct answer. 0.52. What is the ratio of the Imports (BoP, current US$) of Denmark in 2008 to that in 2009?
Give a very brief answer. 1.31. What is the ratio of the Imports (BoP, current US$) in Macedonia in 2008 to that in 2009?
Offer a terse response. 1.33. What is the ratio of the Imports (BoP, current US$) of Slovak Republic in 2008 to that in 2009?
Make the answer very short. 1.29. What is the ratio of the Imports (BoP, current US$) of Tanzania in 2008 to that in 2009?
Offer a very short reply. 1.15. What is the ratio of the Imports (BoP, current US$) of Denmark in 2008 to that in 2010?
Provide a short and direct response. 1.28. What is the ratio of the Imports (BoP, current US$) of Macedonia in 2008 to that in 2010?
Offer a very short reply. 1.25. What is the ratio of the Imports (BoP, current US$) in Slovak Republic in 2008 to that in 2010?
Provide a short and direct response. 1.15. What is the ratio of the Imports (BoP, current US$) of Tanzania in 2008 to that in 2010?
Offer a very short reply. 0.96. What is the ratio of the Imports (BoP, current US$) of Denmark in 2008 to that in 2011?
Your answer should be very brief. 1.11. What is the ratio of the Imports (BoP, current US$) of Macedonia in 2008 to that in 2011?
Offer a very short reply. 0.98. What is the ratio of the Imports (BoP, current US$) in Slovak Republic in 2008 to that in 2011?
Give a very brief answer. 0.95. What is the ratio of the Imports (BoP, current US$) in Tanzania in 2008 to that in 2011?
Provide a short and direct response. 0.72. What is the ratio of the Imports (BoP, current US$) in Denmark in 2009 to that in 2010?
Your answer should be compact. 0.97. What is the ratio of the Imports (BoP, current US$) of Macedonia in 2009 to that in 2010?
Ensure brevity in your answer.  0.94. What is the ratio of the Imports (BoP, current US$) in Slovak Republic in 2009 to that in 2010?
Keep it short and to the point. 0.89. What is the ratio of the Imports (BoP, current US$) in Tanzania in 2009 to that in 2010?
Your answer should be compact. 0.83. What is the ratio of the Imports (BoP, current US$) in Denmark in 2009 to that in 2011?
Your response must be concise. 0.84. What is the ratio of the Imports (BoP, current US$) in Macedonia in 2009 to that in 2011?
Keep it short and to the point. 0.74. What is the ratio of the Imports (BoP, current US$) in Slovak Republic in 2009 to that in 2011?
Provide a succinct answer. 0.73. What is the ratio of the Imports (BoP, current US$) of Tanzania in 2009 to that in 2011?
Offer a very short reply. 0.63. What is the ratio of the Imports (BoP, current US$) in Denmark in 2010 to that in 2011?
Your response must be concise. 0.87. What is the ratio of the Imports (BoP, current US$) of Macedonia in 2010 to that in 2011?
Keep it short and to the point. 0.79. What is the ratio of the Imports (BoP, current US$) of Slovak Republic in 2010 to that in 2011?
Make the answer very short. 0.82. What is the ratio of the Imports (BoP, current US$) of Tanzania in 2010 to that in 2011?
Give a very brief answer. 0.75. What is the difference between the highest and the second highest Imports (BoP, current US$) in Denmark?
Give a very brief answer. 1.71e+1. What is the difference between the highest and the second highest Imports (BoP, current US$) in Macedonia?
Offer a terse response. 1.15e+08. What is the difference between the highest and the second highest Imports (BoP, current US$) in Slovak Republic?
Keep it short and to the point. 4.66e+09. What is the difference between the highest and the second highest Imports (BoP, current US$) in Tanzania?
Keep it short and to the point. 2.98e+09. What is the difference between the highest and the lowest Imports (BoP, current US$) in Denmark?
Provide a short and direct response. 6.47e+1. What is the difference between the highest and the lowest Imports (BoP, current US$) of Macedonia?
Keep it short and to the point. 3.75e+09. What is the difference between the highest and the lowest Imports (BoP, current US$) in Slovak Republic?
Offer a terse response. 4.67e+1. What is the difference between the highest and the lowest Imports (BoP, current US$) in Tanzania?
Provide a short and direct response. 7.83e+09. 